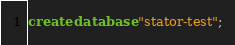Convert code to text. <code><loc_0><loc_0><loc_500><loc_500><_SQL_>create database "stator-test";</code> 